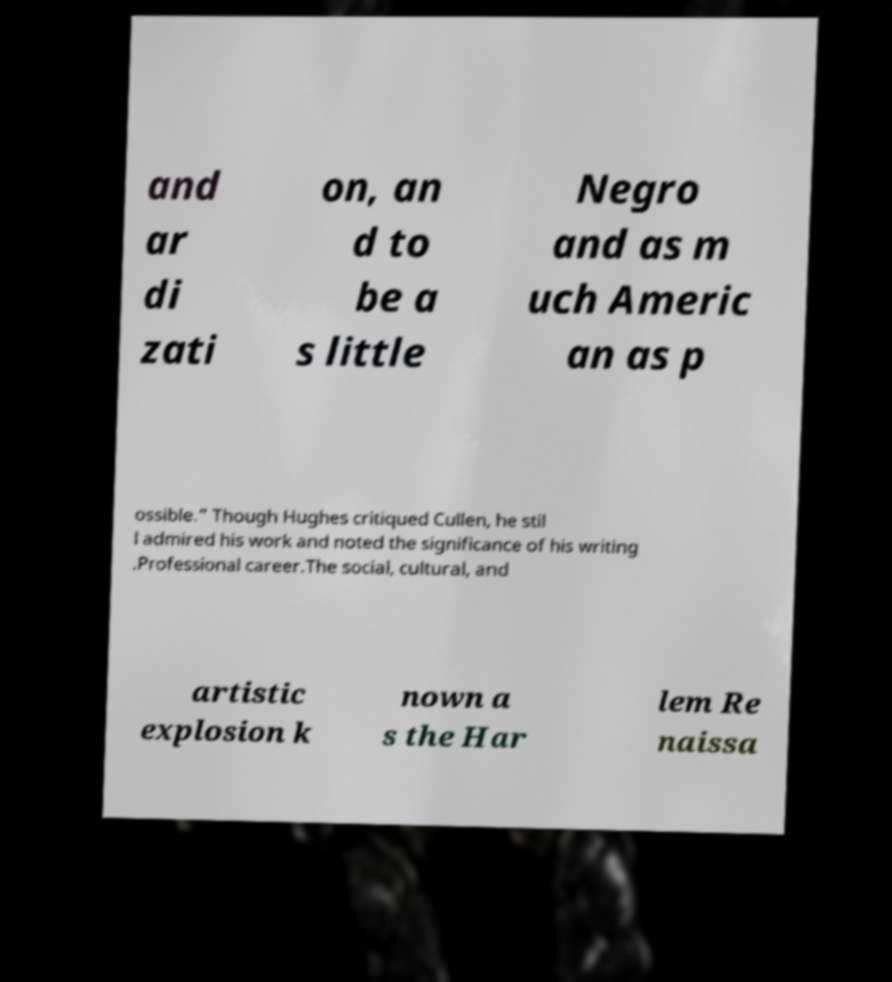Please identify and transcribe the text found in this image. and ar di zati on, an d to be a s little Negro and as m uch Americ an as p ossible.” Though Hughes critiqued Cullen, he stil l admired his work and noted the significance of his writing .Professional career.The social, cultural, and artistic explosion k nown a s the Har lem Re naissa 